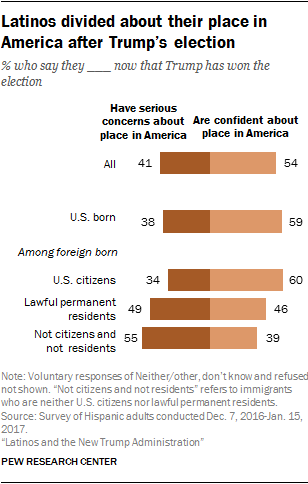How many issues have over 50 approval rates? Based on the provided graph, there are two issues where the approval rate exceeds 50%: 60% of U.S. citizen Latinos are confident about their place in America after Trump's election, and 59% of U.S. born Latinos share this confidence. 